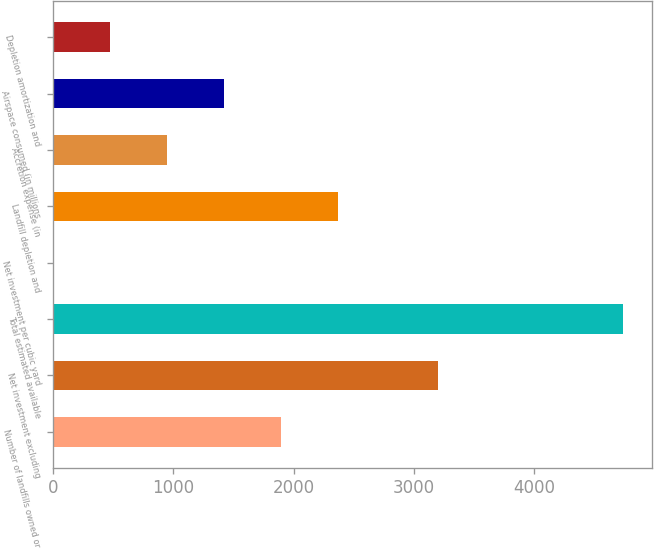Convert chart. <chart><loc_0><loc_0><loc_500><loc_500><bar_chart><fcel>Number of landfills owned or<fcel>Net investment excluding<fcel>Total estimated available<fcel>Net investment per cubic yard<fcel>Landfill depletion and<fcel>Accretion expense (in<fcel>Airspace consumed (in millions<fcel>Depletion amortization and<nl><fcel>1898.24<fcel>3203.8<fcel>4744.6<fcel>0.68<fcel>2372.63<fcel>949.46<fcel>1423.85<fcel>475.07<nl></chart> 